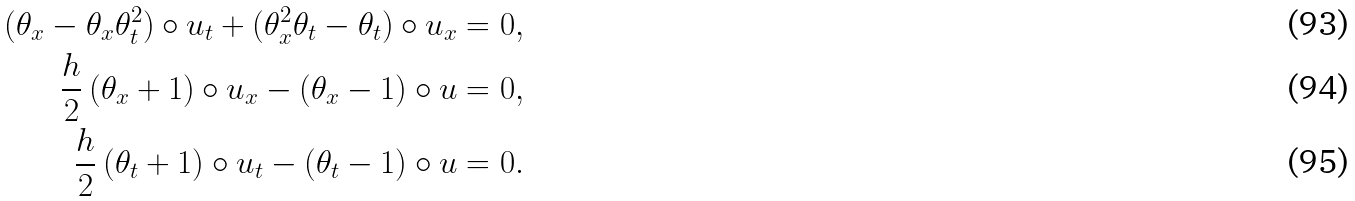<formula> <loc_0><loc_0><loc_500><loc_500>( \theta _ { x } - \theta _ { x } \theta _ { t } ^ { 2 } ) \circ u _ { t } + ( \theta _ { x } ^ { 2 } \theta _ { t } - \theta _ { t } ) \circ u _ { x } = 0 , \\ \frac { h } { 2 } \, ( \theta _ { x } + 1 ) \circ u _ { x } - ( \theta _ { x } - 1 ) \circ u = 0 , \\ \frac { h } { 2 } \, ( \theta _ { t } + 1 ) \circ u _ { t } - ( \theta _ { t } - 1 ) \circ u = 0 .</formula> 